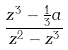Convert formula to latex. <formula><loc_0><loc_0><loc_500><loc_500>\frac { z ^ { 3 } - \frac { 1 } { 3 } a } { z ^ { 2 } - z ^ { 3 } }</formula> 